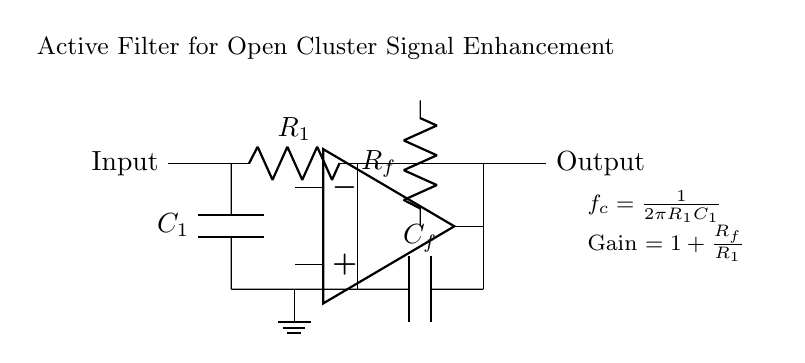What is the type of filter used in this circuit? The circuit is designated as an active filter, as indicated in the title above the diagram. Active filters use active components like operational amplifiers to enhance signal processing capabilities.
Answer: Active Filter What components are present in this active filter circuit? The circuit includes capacitors (C1 and Cf), resistors (R1 and Rf), and an operational amplifier, which are standard elements in filter design.
Answer: Capacitors, Resistors, Operational Amplifier What is the cutoff frequency formula for this circuit? The formula for the cutoff frequency (f_c) is provided in the diagram as f_c = 1 over 2πR1C1. This indicates how frequency response is calculated based on resistor and capacitor values.
Answer: 1 over 2πR1C1 What is the function of the feedback resistor Rf? Rf sets the gain of the amplifier, adjusting how much the output signal is amplified relative to the input signal, as described by the gain formula in the circuit.
Answer: Gain control How does the gain formula depend on the resistors? The gain formula stated in the circuit is Gain = 1 plus Rf over R1. This means that the gain increases as Rf increases or R1 decreases, indicating that these resistor values are critical for determining amplification.
Answer: Gain = 1 + Rf over R1 What is the role of the capacitor C1 in the circuit? The capacitor C1 is used for filtering high-frequency noise and allows lower frequency signals to pass, which is essential for effectively enhancing the weak signals from distant open clusters.
Answer: Low-pass filtering 